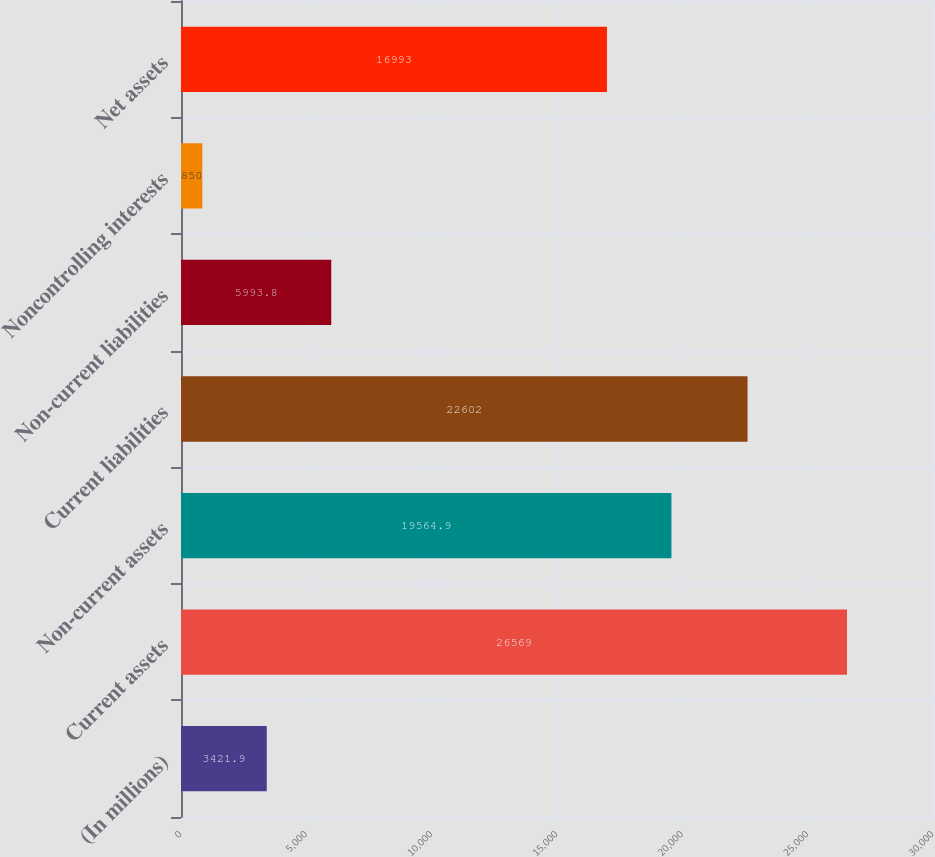Convert chart. <chart><loc_0><loc_0><loc_500><loc_500><bar_chart><fcel>(In millions)<fcel>Current assets<fcel>Non-current assets<fcel>Current liabilities<fcel>Non-current liabilities<fcel>Noncontrolling interests<fcel>Net assets<nl><fcel>3421.9<fcel>26569<fcel>19564.9<fcel>22602<fcel>5993.8<fcel>850<fcel>16993<nl></chart> 